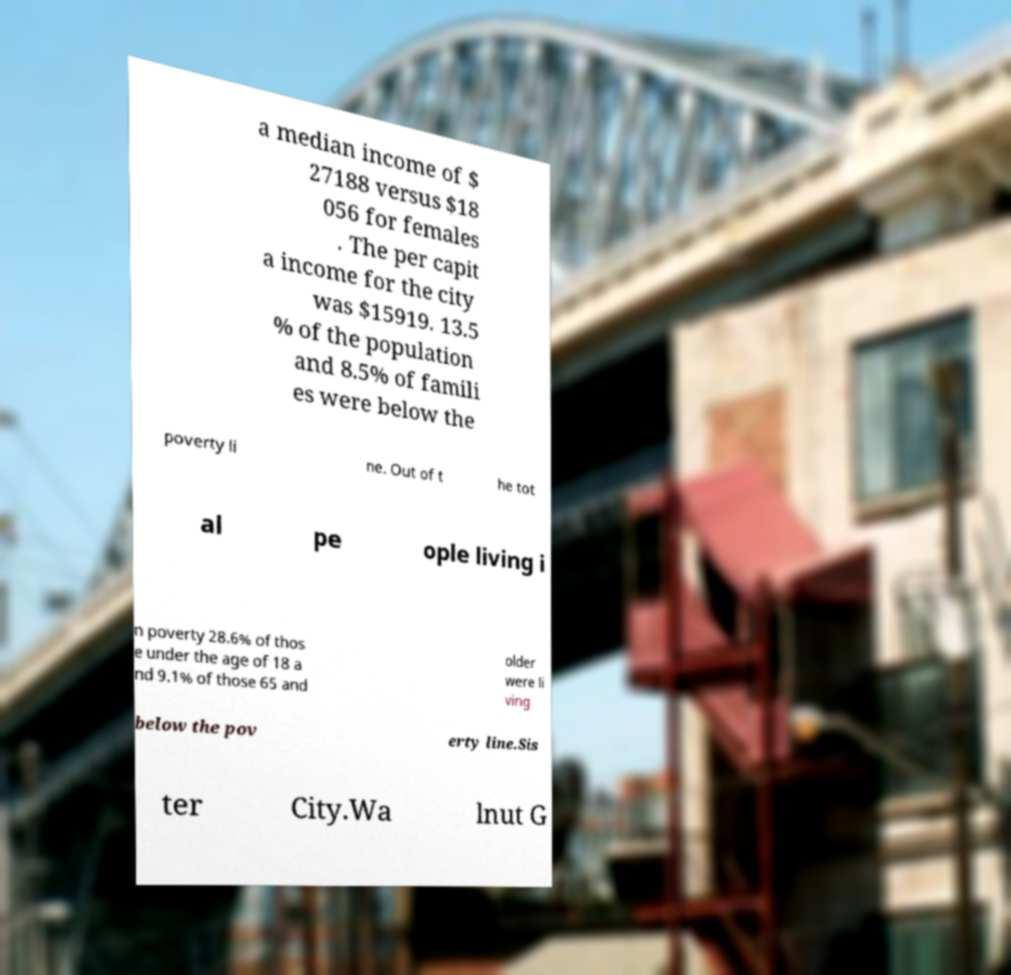Can you read and provide the text displayed in the image?This photo seems to have some interesting text. Can you extract and type it out for me? a median income of $ 27188 versus $18 056 for females . The per capit a income for the city was $15919. 13.5 % of the population and 8.5% of famili es were below the poverty li ne. Out of t he tot al pe ople living i n poverty 28.6% of thos e under the age of 18 a nd 9.1% of those 65 and older were li ving below the pov erty line.Sis ter City.Wa lnut G 